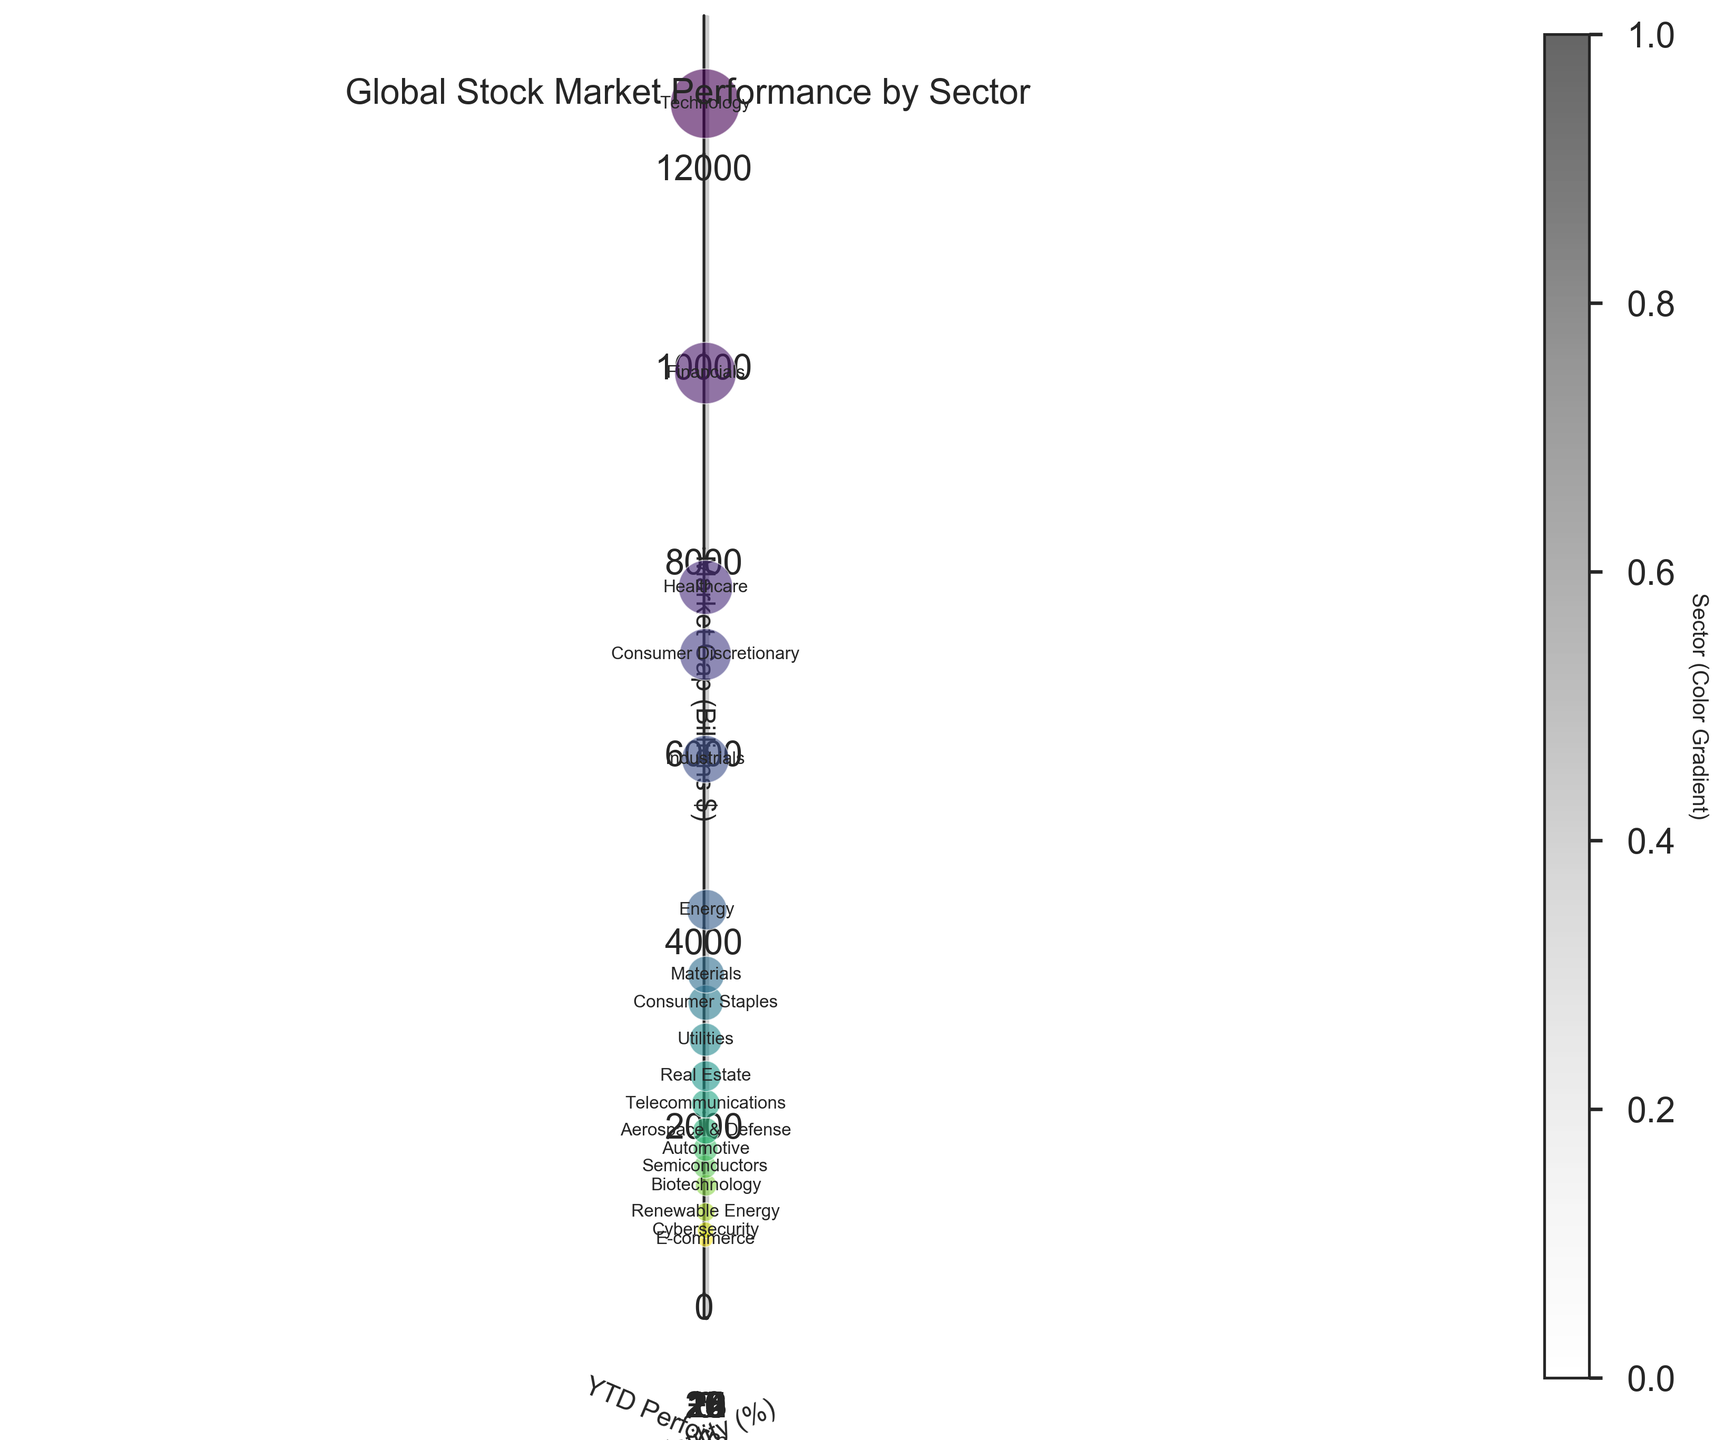What's the title of the figure? The title of the figure is displayed at the top of the plot. It provides a summary of what the figure represents. It is often the first thing that one would notice when looking at a plot.
Answer: Global Stock Market Performance by Sector How many sectors are represented in the figure? By counting the number of distinct data points (bubbles) in the plot, one evaluates how many sectors are represented. Each bubble corresponds to one sector.
Answer: 18 Which sector has the highest market capitalization? The sector with the highest market capitalization will have the largest bubble size and higher z-axis value. Observing the figure and comparing bubble sizes helps identify the largest.
Answer: Technology Which sector has the highest volatility? The sector with the highest volatility will be plotted farthest along the x-axis. One can find this by looking for the bubble at the furthest right along the x-axis.
Answer: Renewable Energy How does the market capitalization of the Semiconductor sector compare to the Biotechnology sector? To compare the market capitalization, we need to compare the z-axis values (height) of their respective bubbles. One must locate each sector's bubble and observe which is taller.
Answer: The Semiconductor sector has a higher market capitalization than the Biotechnology sector Which sector has the lowest Year-to-Date (YTD) performance? The sector with the lowest Year-to-Date performance will have the bubble positioned lowest on the y-axis. Identifying which bubble is at the lowest y-coordinate gives the answer.
Answer: Energy How does the volatility of the Financials sector compare to that of the Cybersecurity sector? To compare volatility, observe the x-axis positions of the Financials and Cybersecurity sectors. A higher x-coordinate means higher volatility.
Answer: Cybersecurity has higher volatility than Financials Which sector has a higher performance YTD, Consumer Discretionary or E-commerce? By examining their positions on the y-axis, one can determine which sector has a higher YTD performance. The sector with the bubble higher on the y-axis has a better performance.
Answer: Consumer Discretionary What's the general trend between volatility and performance YTD? By analyzing the scatter of bubbles across the x-axis (volatility) and y-axis (performance YTD), one can infer the general relationship. Look for a positive, negative, or no clear trend.
Answer: No clear trend 